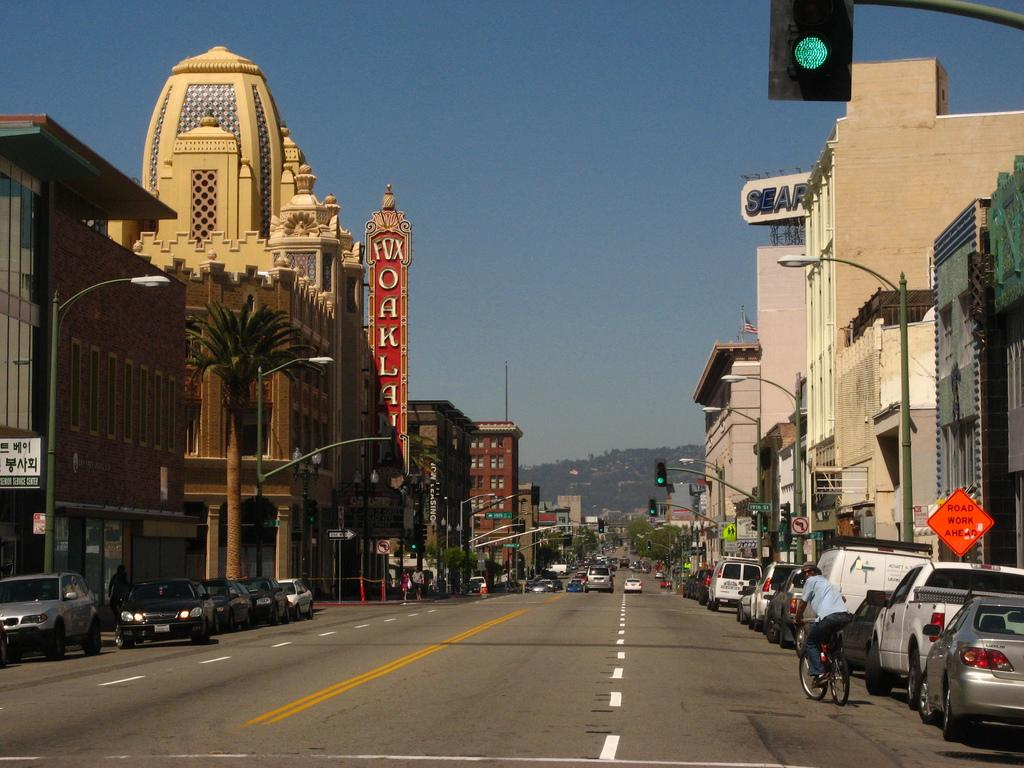What can be seen on the road in the image? There are vehicles on the road in the image. What else is visible in the image besides the vehicles? There are buildings, trees, boards, and a signal light visible in the image. What type of throat medicine is advertised on the boards in the image? There are no boards advertising throat medicine in the image. 